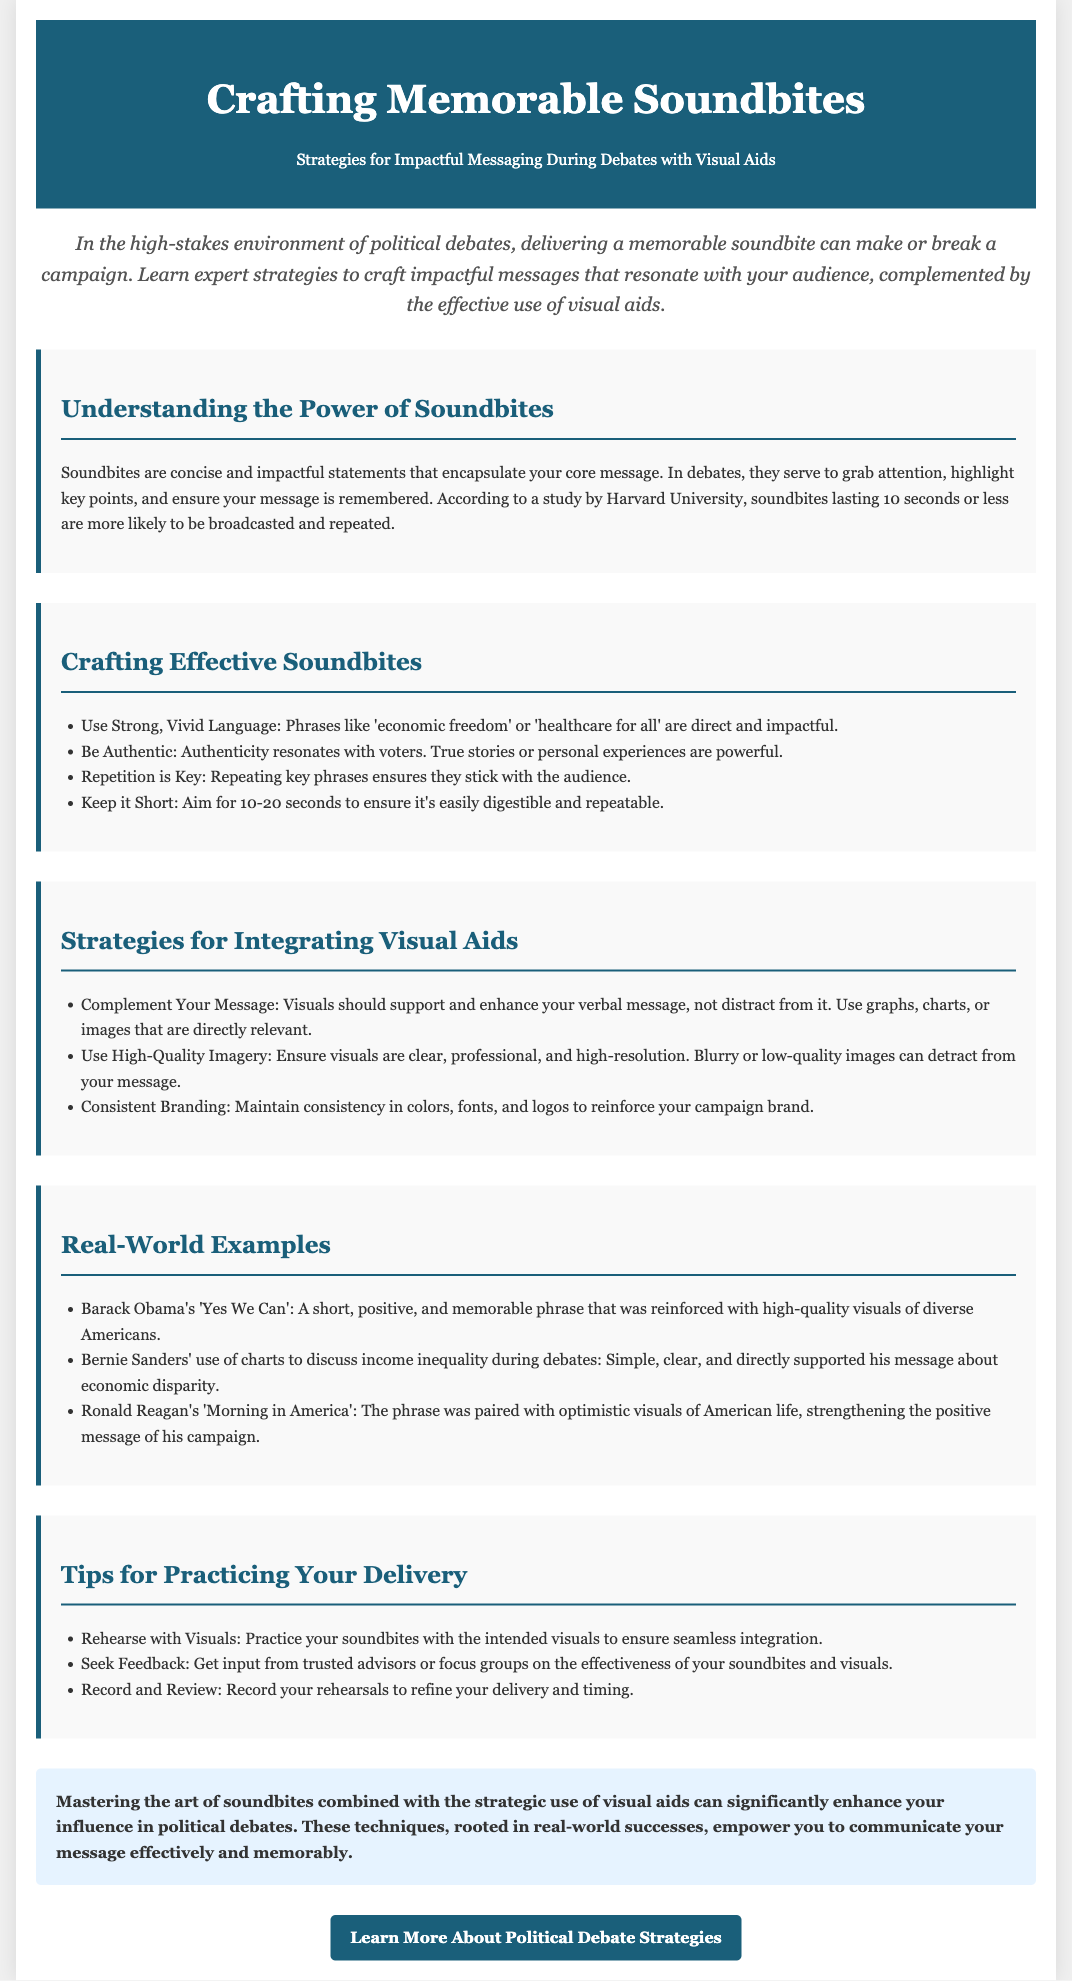What are soundbites? Soundbites are concise and impactful statements that encapsulate your core message.
Answer: Concise and impactful statements What is the ideal length for a soundbite? Aim for 10-20 seconds to ensure it's easily digestible and repeatable.
Answer: 10-20 seconds Which campaign used "Yes We Can"? Barack Obama's campaign used the phrase "Yes We Can".
Answer: Barack Obama What should visuals do in a debate? Visuals should support and enhance your verbal message, not distract from it.
Answer: Support and enhance How often should key phrases be repeated? Repetition of key phrases ensures they stick with the audience.
Answer: Always What is a strategy for practicing soundbite delivery? Practice your soundbites with the intended visuals to ensure seamless integration.
Answer: Rehearse with visuals What type of imagery should be used in visuals? Ensure visuals are clear, professional, and high-resolution.
Answer: High-quality imagery What is the concluding statement about soundbites and visuals? Mastering the art of soundbites combined with the strategic use of visual aids can significantly enhance your influence in political debates.
Answer: Enhance your influence What campaign used charts to discuss income inequality? Bernie Sanders' campaign used charts to discuss income inequality.
Answer: Bernie Sanders 